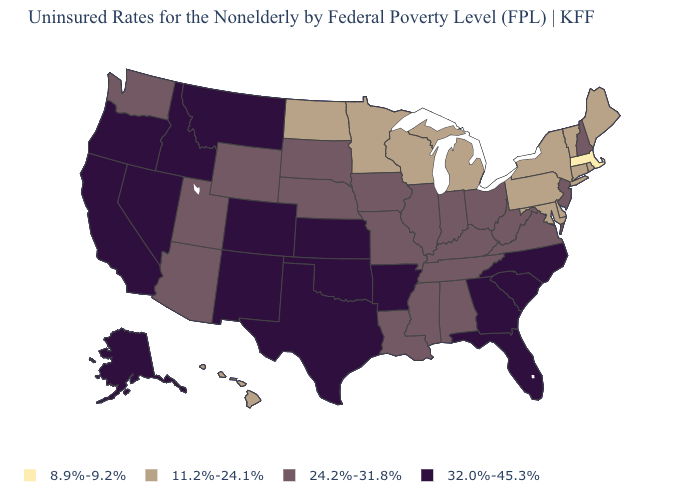What is the highest value in states that border New Hampshire?
Write a very short answer. 11.2%-24.1%. What is the lowest value in states that border Vermont?
Keep it brief. 8.9%-9.2%. Among the states that border Missouri , does Oklahoma have the highest value?
Quick response, please. Yes. What is the value of New Hampshire?
Concise answer only. 24.2%-31.8%. What is the value of South Carolina?
Keep it brief. 32.0%-45.3%. Does Minnesota have a lower value than Rhode Island?
Be succinct. No. Which states have the highest value in the USA?
Give a very brief answer. Alaska, Arkansas, California, Colorado, Florida, Georgia, Idaho, Kansas, Montana, Nevada, New Mexico, North Carolina, Oklahoma, Oregon, South Carolina, Texas. How many symbols are there in the legend?
Quick response, please. 4. What is the highest value in states that border South Dakota?
Concise answer only. 32.0%-45.3%. Among the states that border Maryland , does Virginia have the lowest value?
Short answer required. No. Name the states that have a value in the range 8.9%-9.2%?
Answer briefly. Massachusetts. Does Texas have the same value as California?
Quick response, please. Yes. Does Missouri have a higher value than Vermont?
Concise answer only. Yes. Which states have the lowest value in the USA?
Short answer required. Massachusetts. Is the legend a continuous bar?
Short answer required. No. 